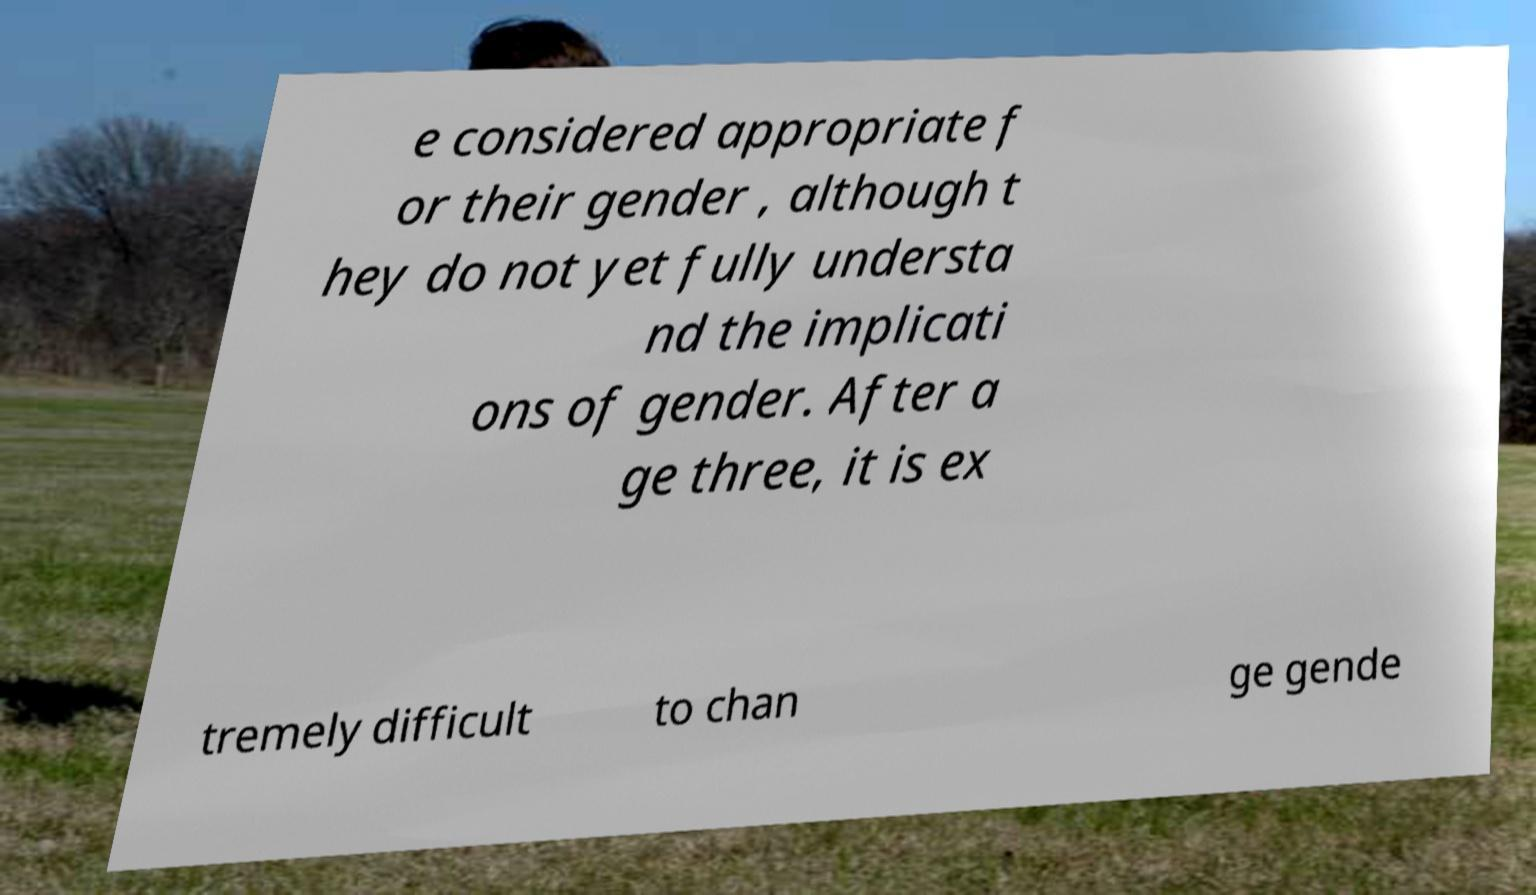What messages or text are displayed in this image? I need them in a readable, typed format. e considered appropriate f or their gender , although t hey do not yet fully understa nd the implicati ons of gender. After a ge three, it is ex tremely difficult to chan ge gende 